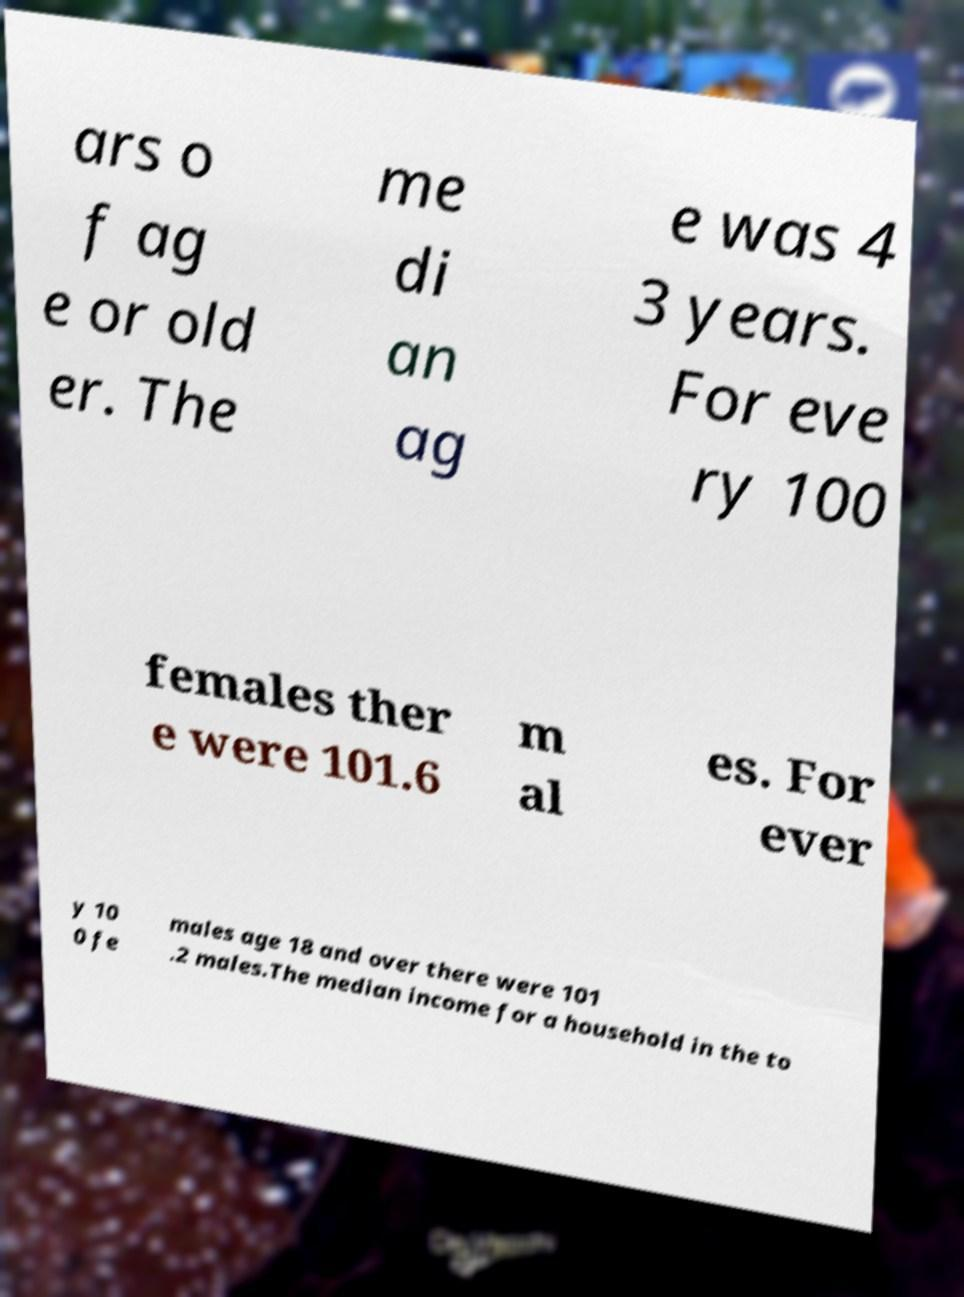Please read and relay the text visible in this image. What does it say? ars o f ag e or old er. The me di an ag e was 4 3 years. For eve ry 100 females ther e were 101.6 m al es. For ever y 10 0 fe males age 18 and over there were 101 .2 males.The median income for a household in the to 